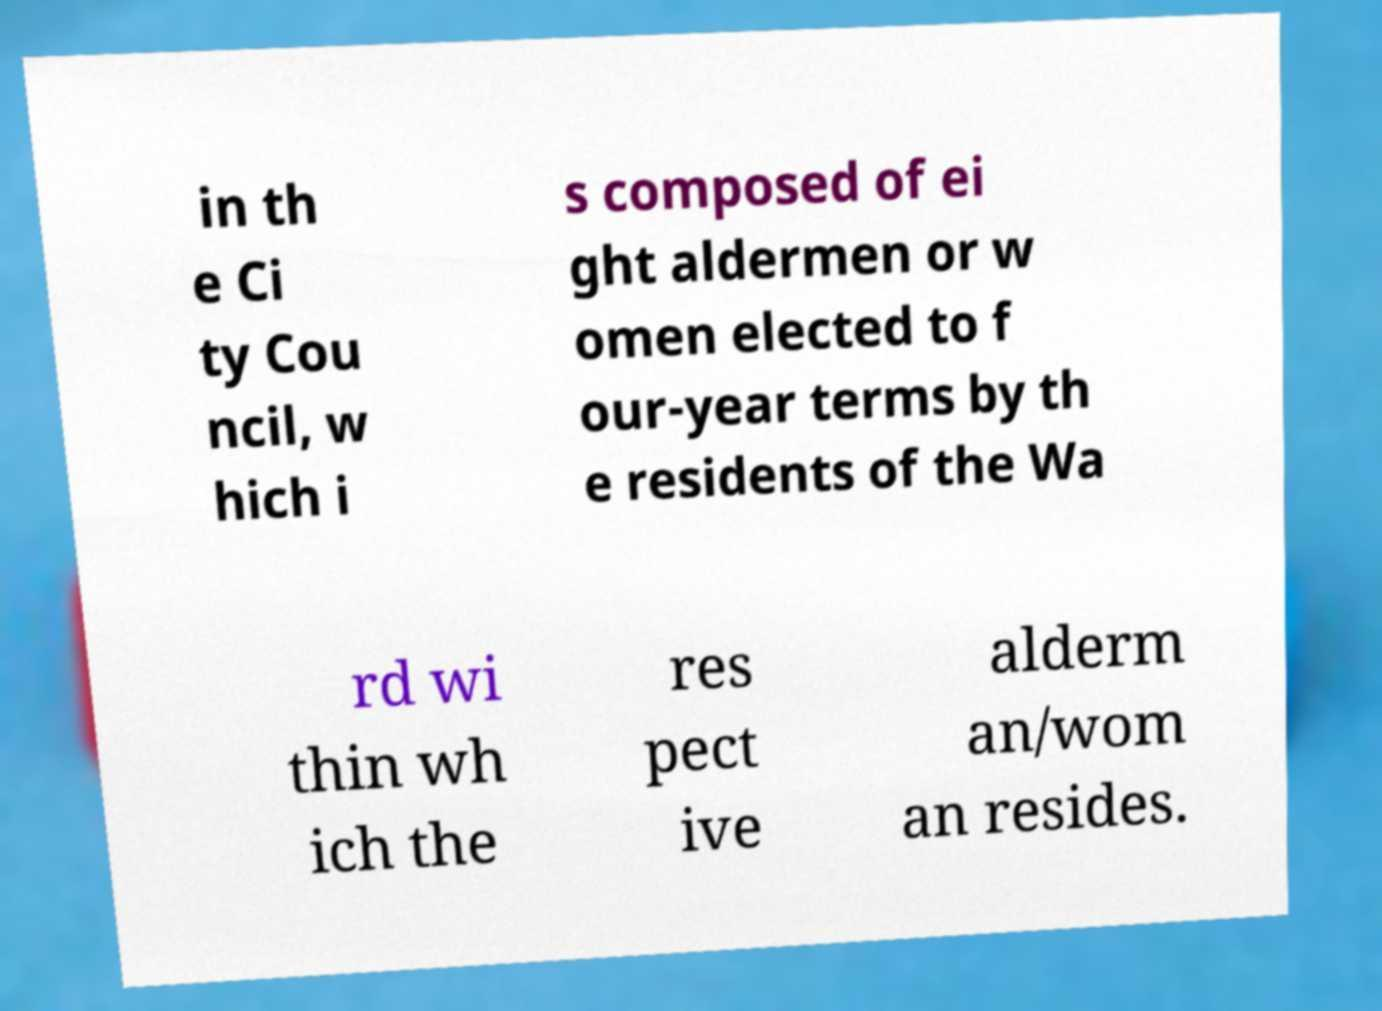There's text embedded in this image that I need extracted. Can you transcribe it verbatim? in th e Ci ty Cou ncil, w hich i s composed of ei ght aldermen or w omen elected to f our-year terms by th e residents of the Wa rd wi thin wh ich the res pect ive alderm an/wom an resides. 